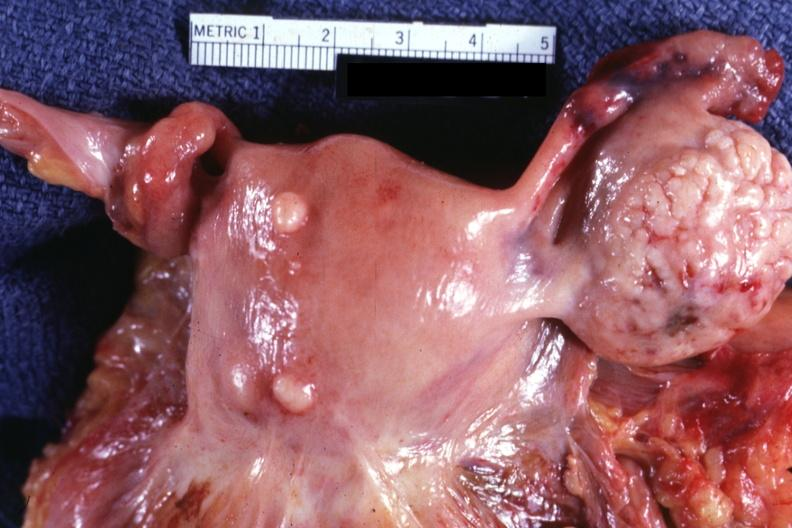what are intramural one lesion is in photo?
Answer the question using a single word or phrase. Small normal ovary 